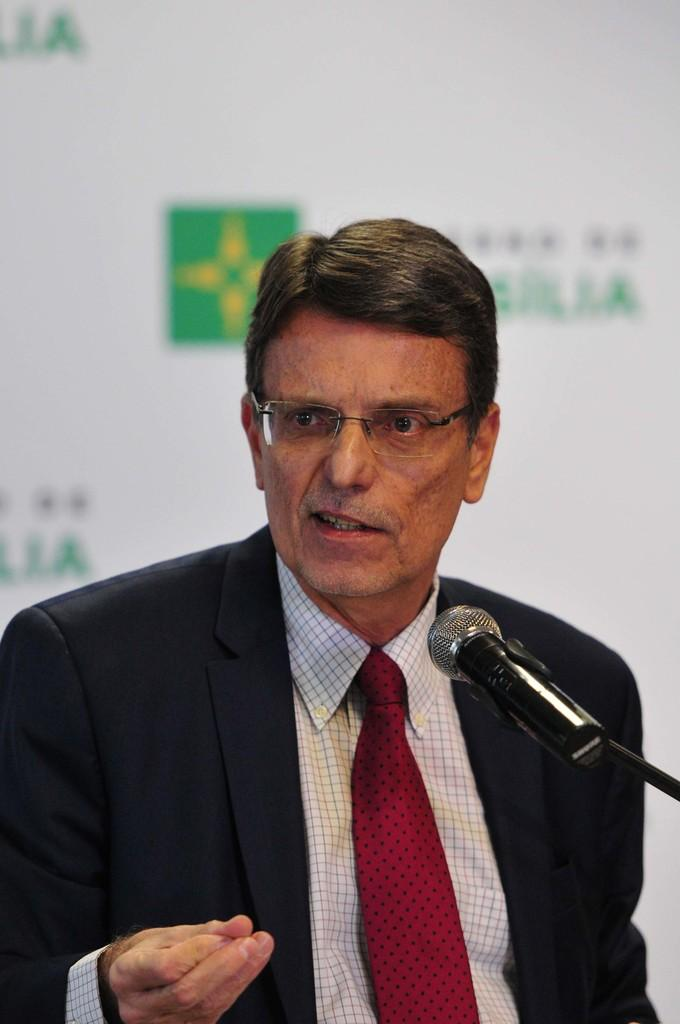Who is the main subject in the image? There is a man in the middle of the image. What object is in front of the man? There is a microphone (mic) in front of the man. What can be seen in the background of the image? There is a banner in the background of the image. How many sticks are being used by the man in the image? There are no sticks present in the image. 